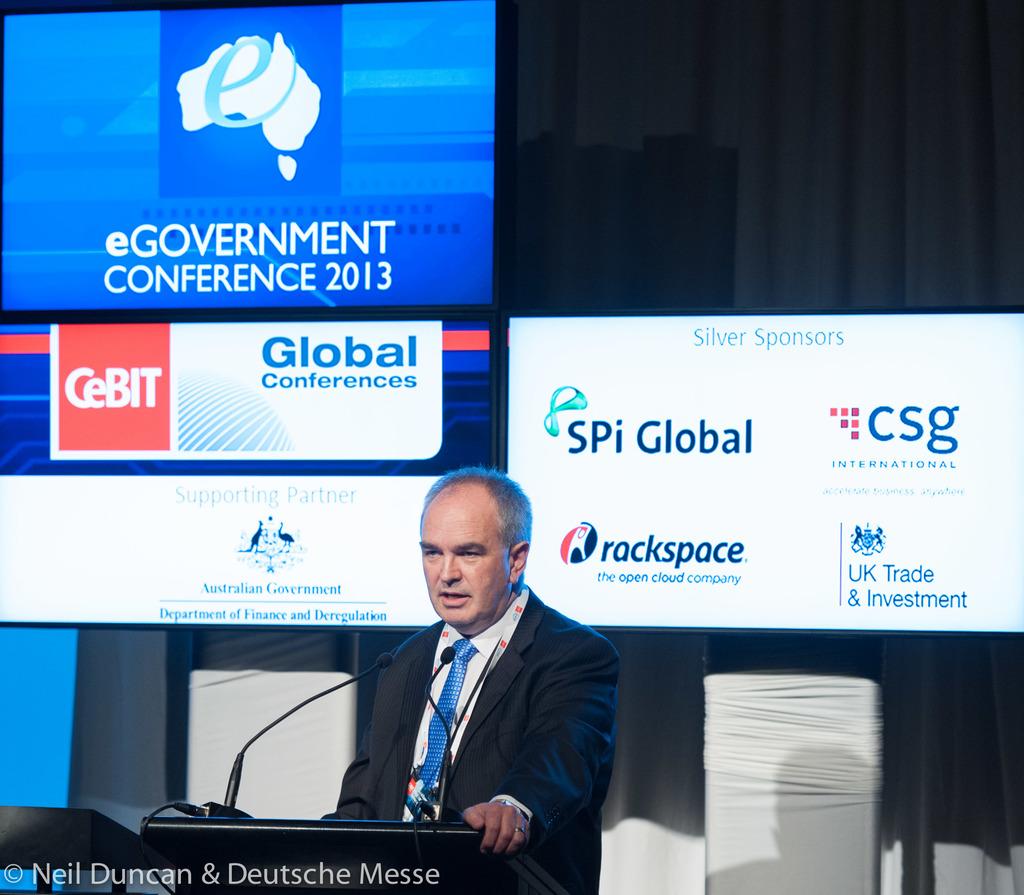When was this conference?
Give a very brief answer. 2013. What are the three letters to the right of the sign that is to the right of the speaker?
Make the answer very short. Csg. 